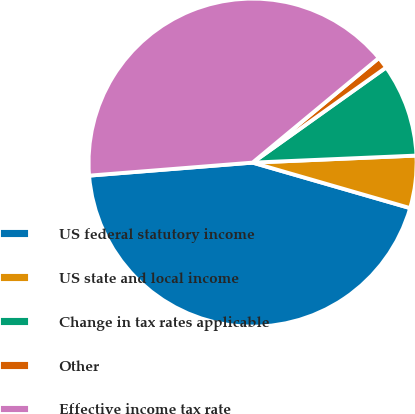Convert chart. <chart><loc_0><loc_0><loc_500><loc_500><pie_chart><fcel>US federal statutory income<fcel>US state and local income<fcel>Change in tax rates applicable<fcel>Other<fcel>Effective income tax rate<nl><fcel>44.26%<fcel>5.16%<fcel>9.17%<fcel>1.16%<fcel>40.25%<nl></chart> 